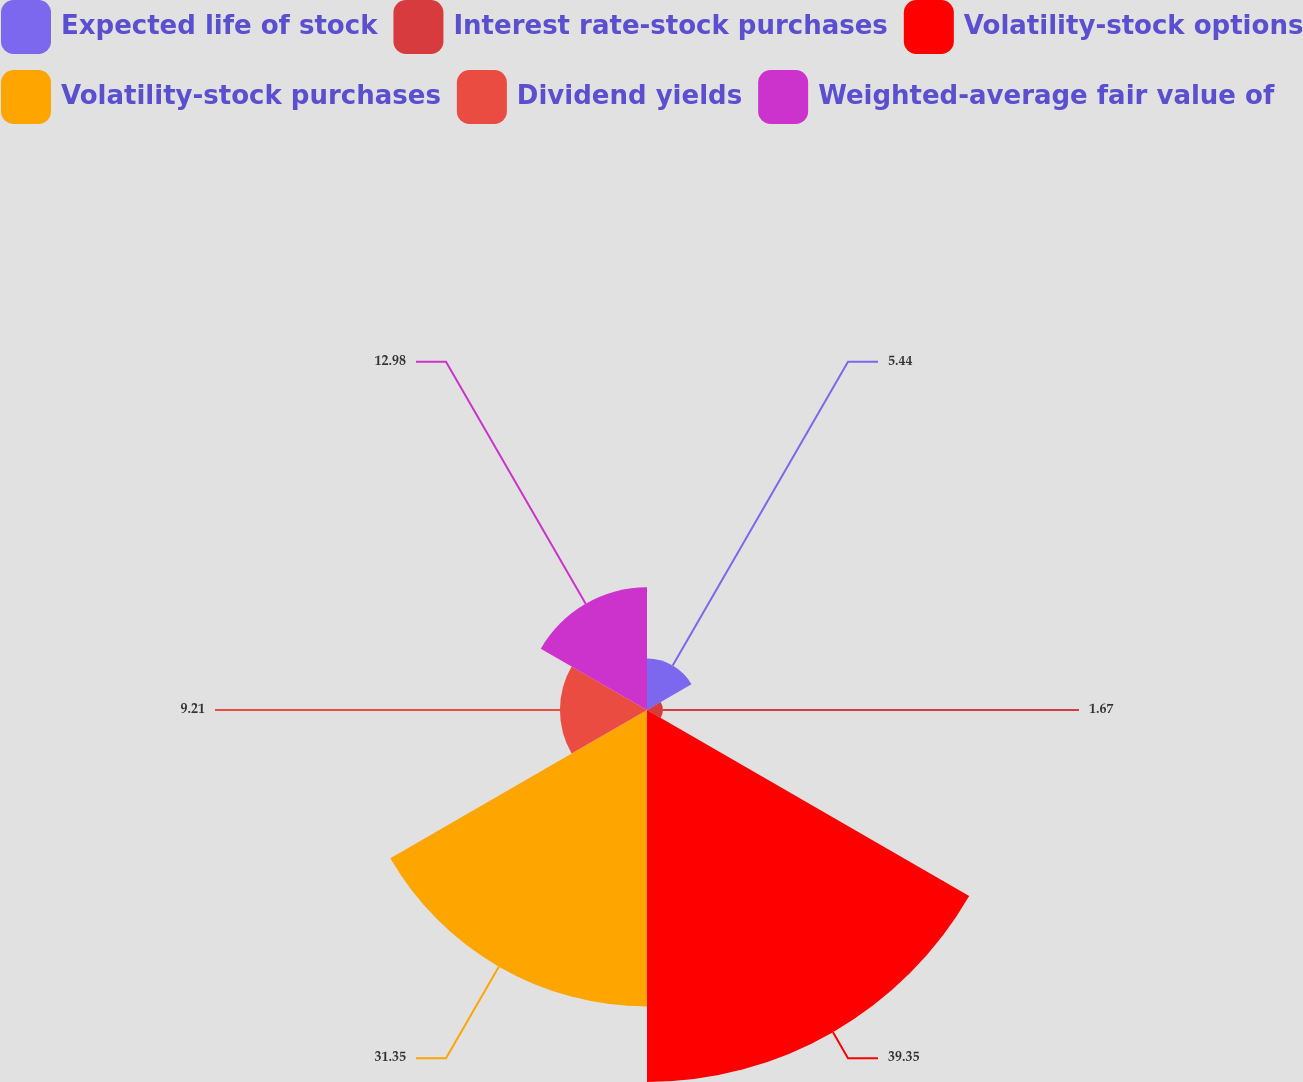Convert chart to OTSL. <chart><loc_0><loc_0><loc_500><loc_500><pie_chart><fcel>Expected life of stock<fcel>Interest rate-stock purchases<fcel>Volatility-stock options<fcel>Volatility-stock purchases<fcel>Dividend yields<fcel>Weighted-average fair value of<nl><fcel>5.44%<fcel>1.67%<fcel>39.36%<fcel>31.36%<fcel>9.21%<fcel>12.98%<nl></chart> 